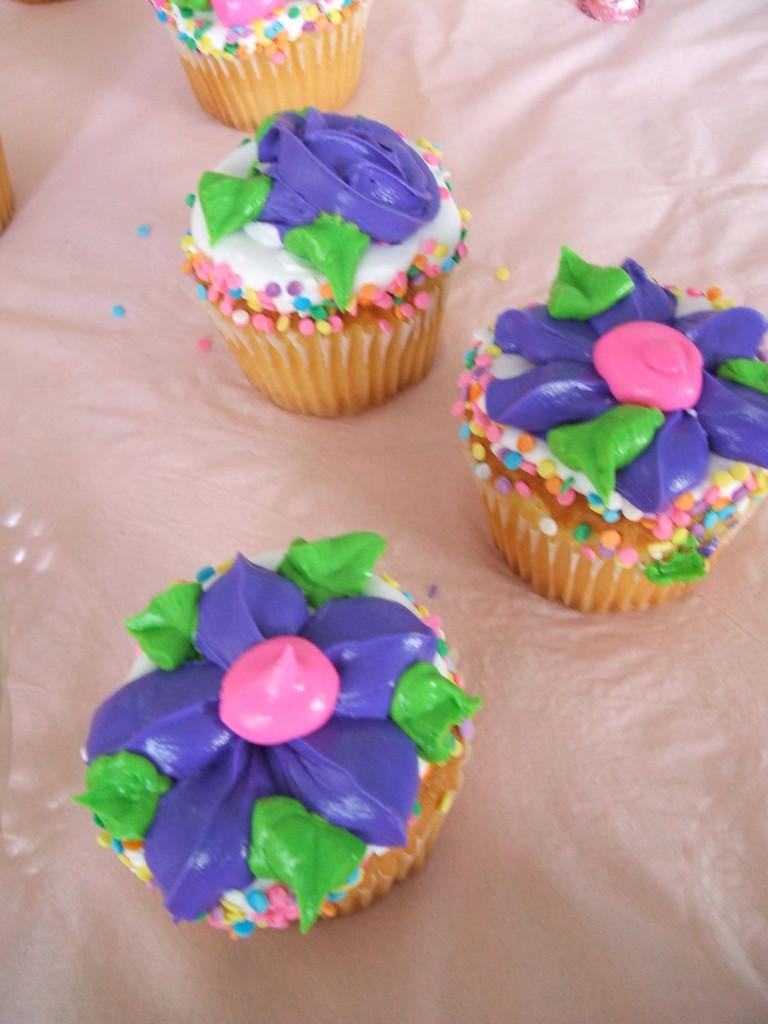How many cupcakes are visible on the white surface in the image? There are four cupcakes on a white surface in the image. What colors are the creams on the cupcakes? The cupcakes have violet, green, and pink cream on them. Can you describe the flight of the egg in the image? There is no egg present in the image, so it is not possible to describe its flight. 